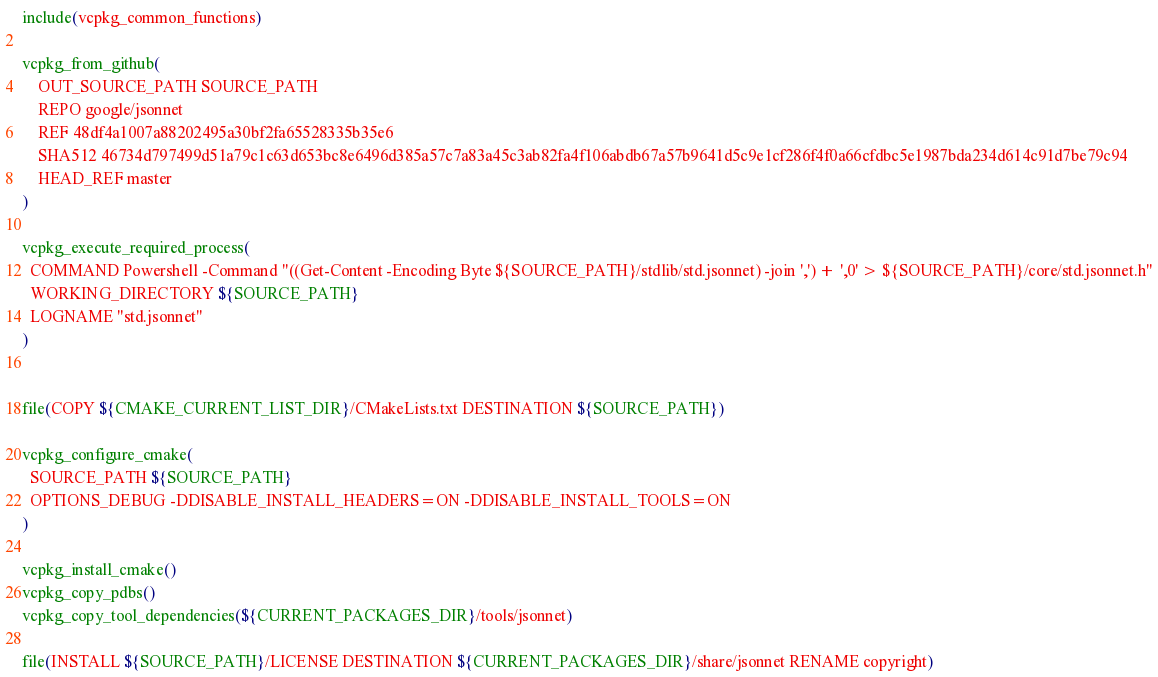<code> <loc_0><loc_0><loc_500><loc_500><_CMake_>include(vcpkg_common_functions)

vcpkg_from_github(
    OUT_SOURCE_PATH SOURCE_PATH
    REPO google/jsonnet
    REF 48df4a1007a88202495a30bf2fa65528335b35e6
    SHA512 46734d797499d51a79c1c63d653bc8e6496d385a57c7a83a45c3ab82fa4f106abdb67a57b9641d5c9e1cf286f4f0a66cfdbc5e1987bda234d614c91d7be79c94
    HEAD_REF master
)

vcpkg_execute_required_process(
  COMMAND Powershell -Command "((Get-Content -Encoding Byte ${SOURCE_PATH}/stdlib/std.jsonnet) -join ',') + ',0' > ${SOURCE_PATH}/core/std.jsonnet.h"
  WORKING_DIRECTORY ${SOURCE_PATH}
  LOGNAME "std.jsonnet"
)


file(COPY ${CMAKE_CURRENT_LIST_DIR}/CMakeLists.txt DESTINATION ${SOURCE_PATH})

vcpkg_configure_cmake(
  SOURCE_PATH ${SOURCE_PATH}
  OPTIONS_DEBUG -DDISABLE_INSTALL_HEADERS=ON -DDISABLE_INSTALL_TOOLS=ON
)

vcpkg_install_cmake()
vcpkg_copy_pdbs()
vcpkg_copy_tool_dependencies(${CURRENT_PACKAGES_DIR}/tools/jsonnet)

file(INSTALL ${SOURCE_PATH}/LICENSE DESTINATION ${CURRENT_PACKAGES_DIR}/share/jsonnet RENAME copyright)
</code> 